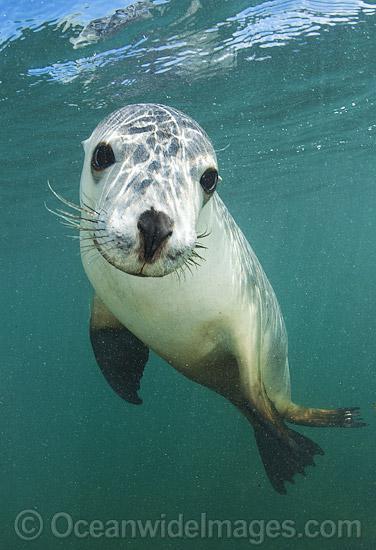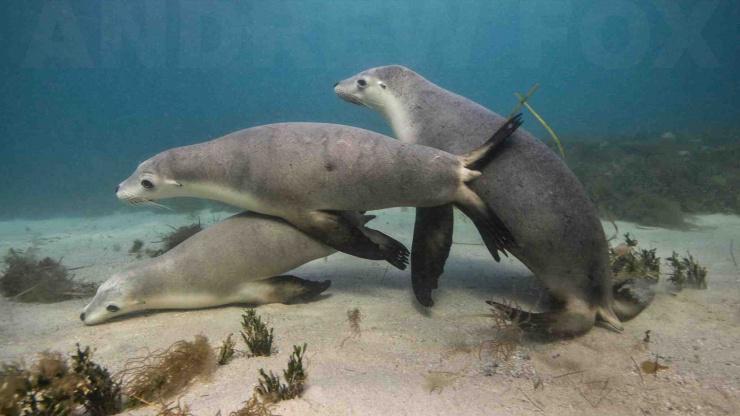The first image is the image on the left, the second image is the image on the right. Given the left and right images, does the statement "In the left image, there's only one seal and it's looking directly at the camera." hold true? Answer yes or no. Yes. The first image is the image on the left, the second image is the image on the right. Analyze the images presented: Is the assertion "A single seal is face to face with the camera in the image on the left." valid? Answer yes or no. Yes. The first image is the image on the left, the second image is the image on the right. For the images shown, is this caption "In one image there are at least six sea lions." true? Answer yes or no. No. The first image is the image on the left, the second image is the image on the right. Assess this claim about the two images: "An image shows a camera-facing seal with at least four other seals underwater in the background.". Correct or not? Answer yes or no. No. 